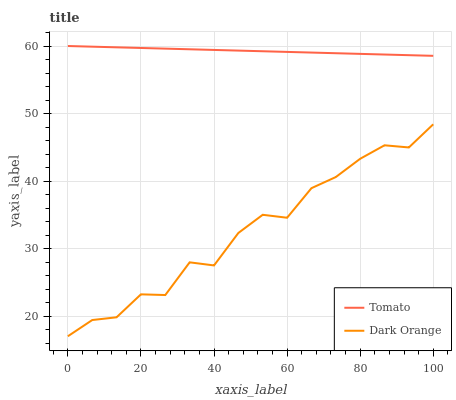Does Dark Orange have the maximum area under the curve?
Answer yes or no. No. Is Dark Orange the smoothest?
Answer yes or no. No. Does Dark Orange have the highest value?
Answer yes or no. No. Is Dark Orange less than Tomato?
Answer yes or no. Yes. Is Tomato greater than Dark Orange?
Answer yes or no. Yes. Does Dark Orange intersect Tomato?
Answer yes or no. No. 